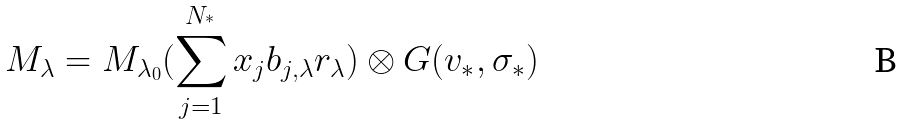<formula> <loc_0><loc_0><loc_500><loc_500>M _ { \lambda } = M _ { \lambda _ { 0 } } ( \sum _ { j = 1 } ^ { N _ { ^ { * } } } x _ { j } b _ { j , \lambda } r _ { \lambda } ) \otimes G ( v _ { \ast } , \sigma _ { \ast } )</formula> 